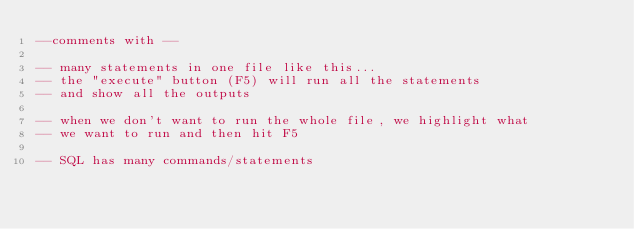<code> <loc_0><loc_0><loc_500><loc_500><_SQL_>--comments with --

-- many statements in one file like this...
-- the "execute" button (F5) will run all the statements
-- and show all the outputs

-- when we don't want to run the whole file, we highlight what
-- we want to run and then hit F5

-- SQL has many commands/statements</code> 